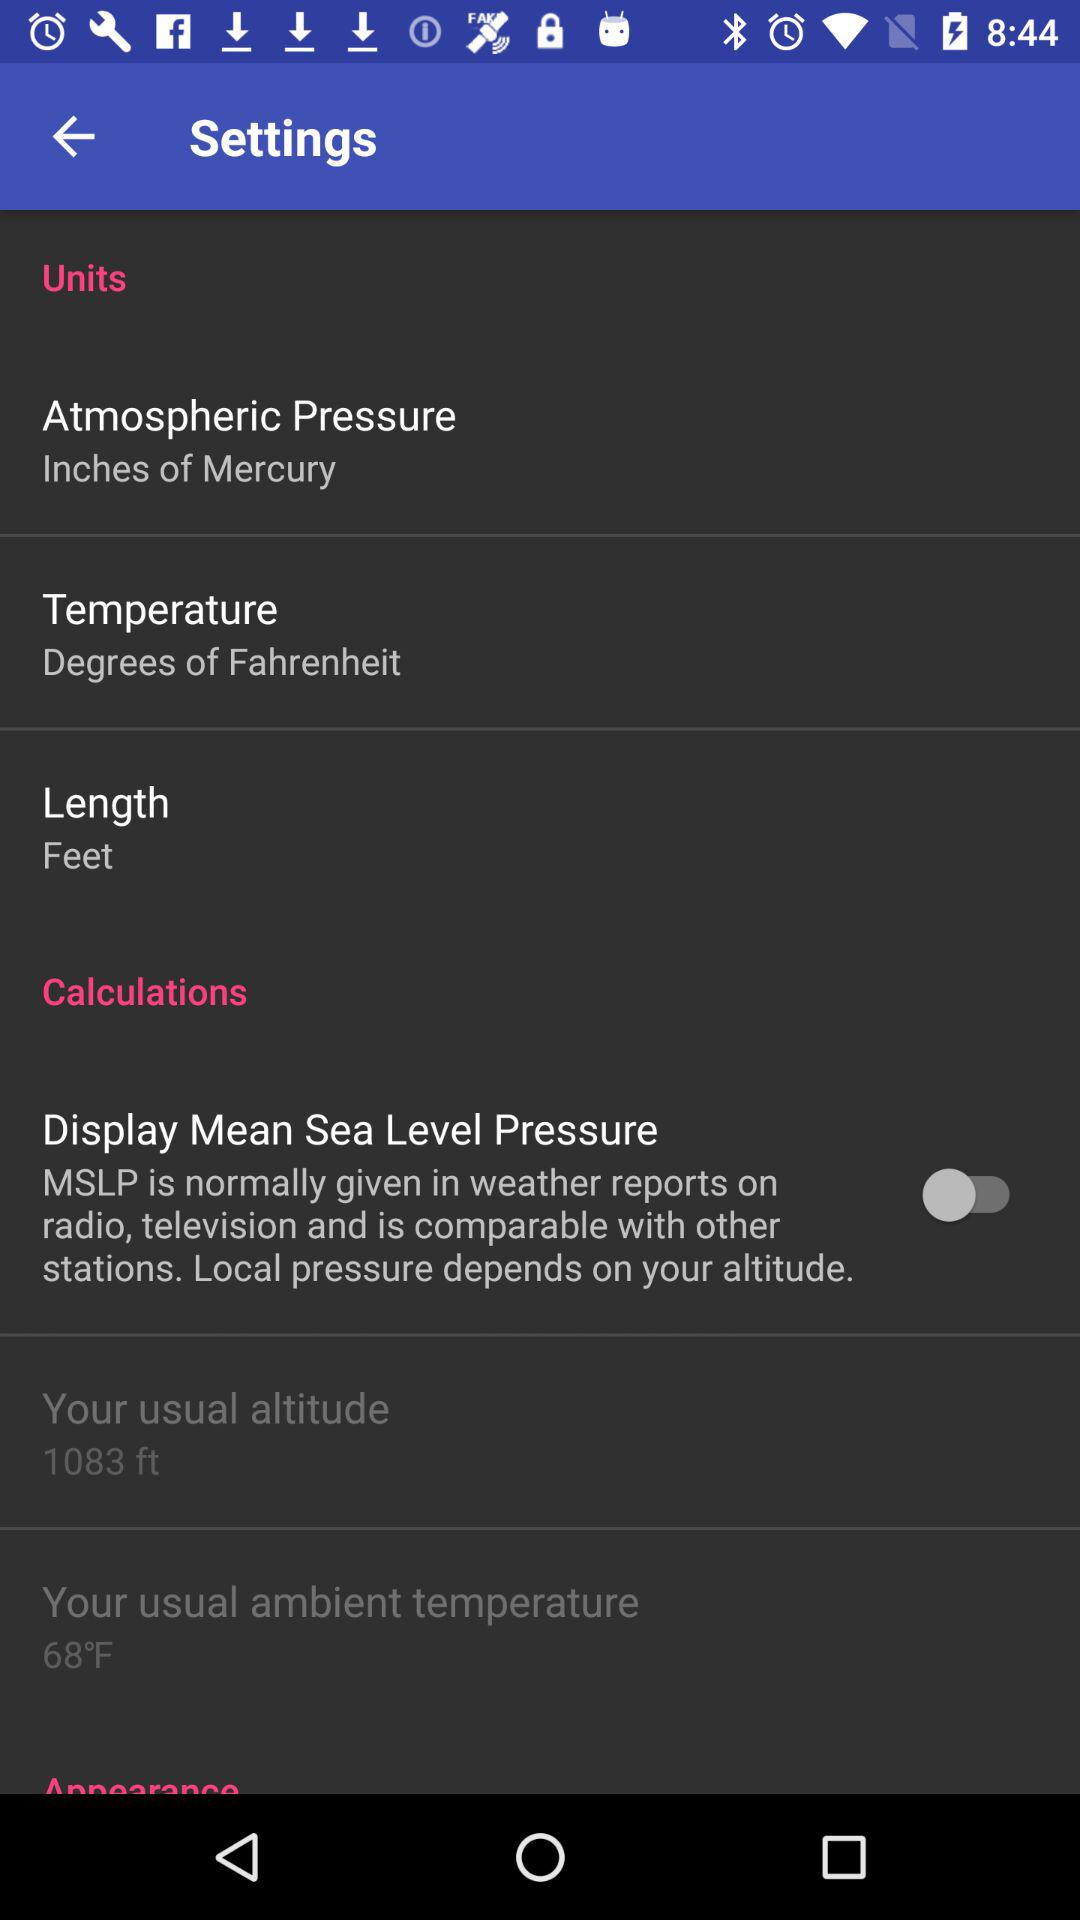What is the unit of atmospheric pressure? The unit of atmospheric pressure is inches of mercury. 